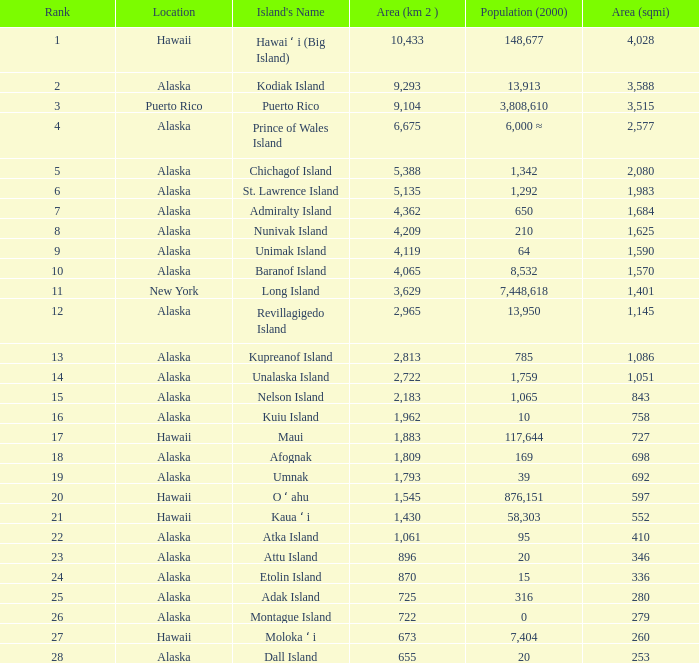What is the highest rank for Nelson Island with area more than 2,183? None. 